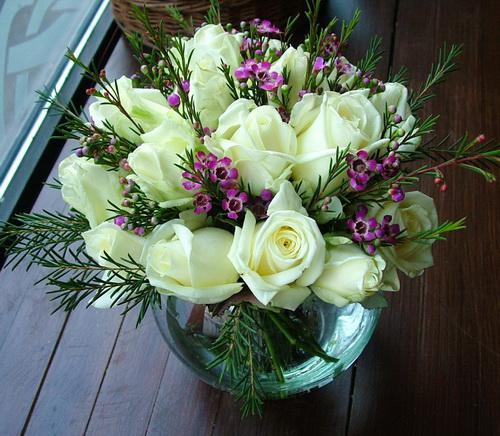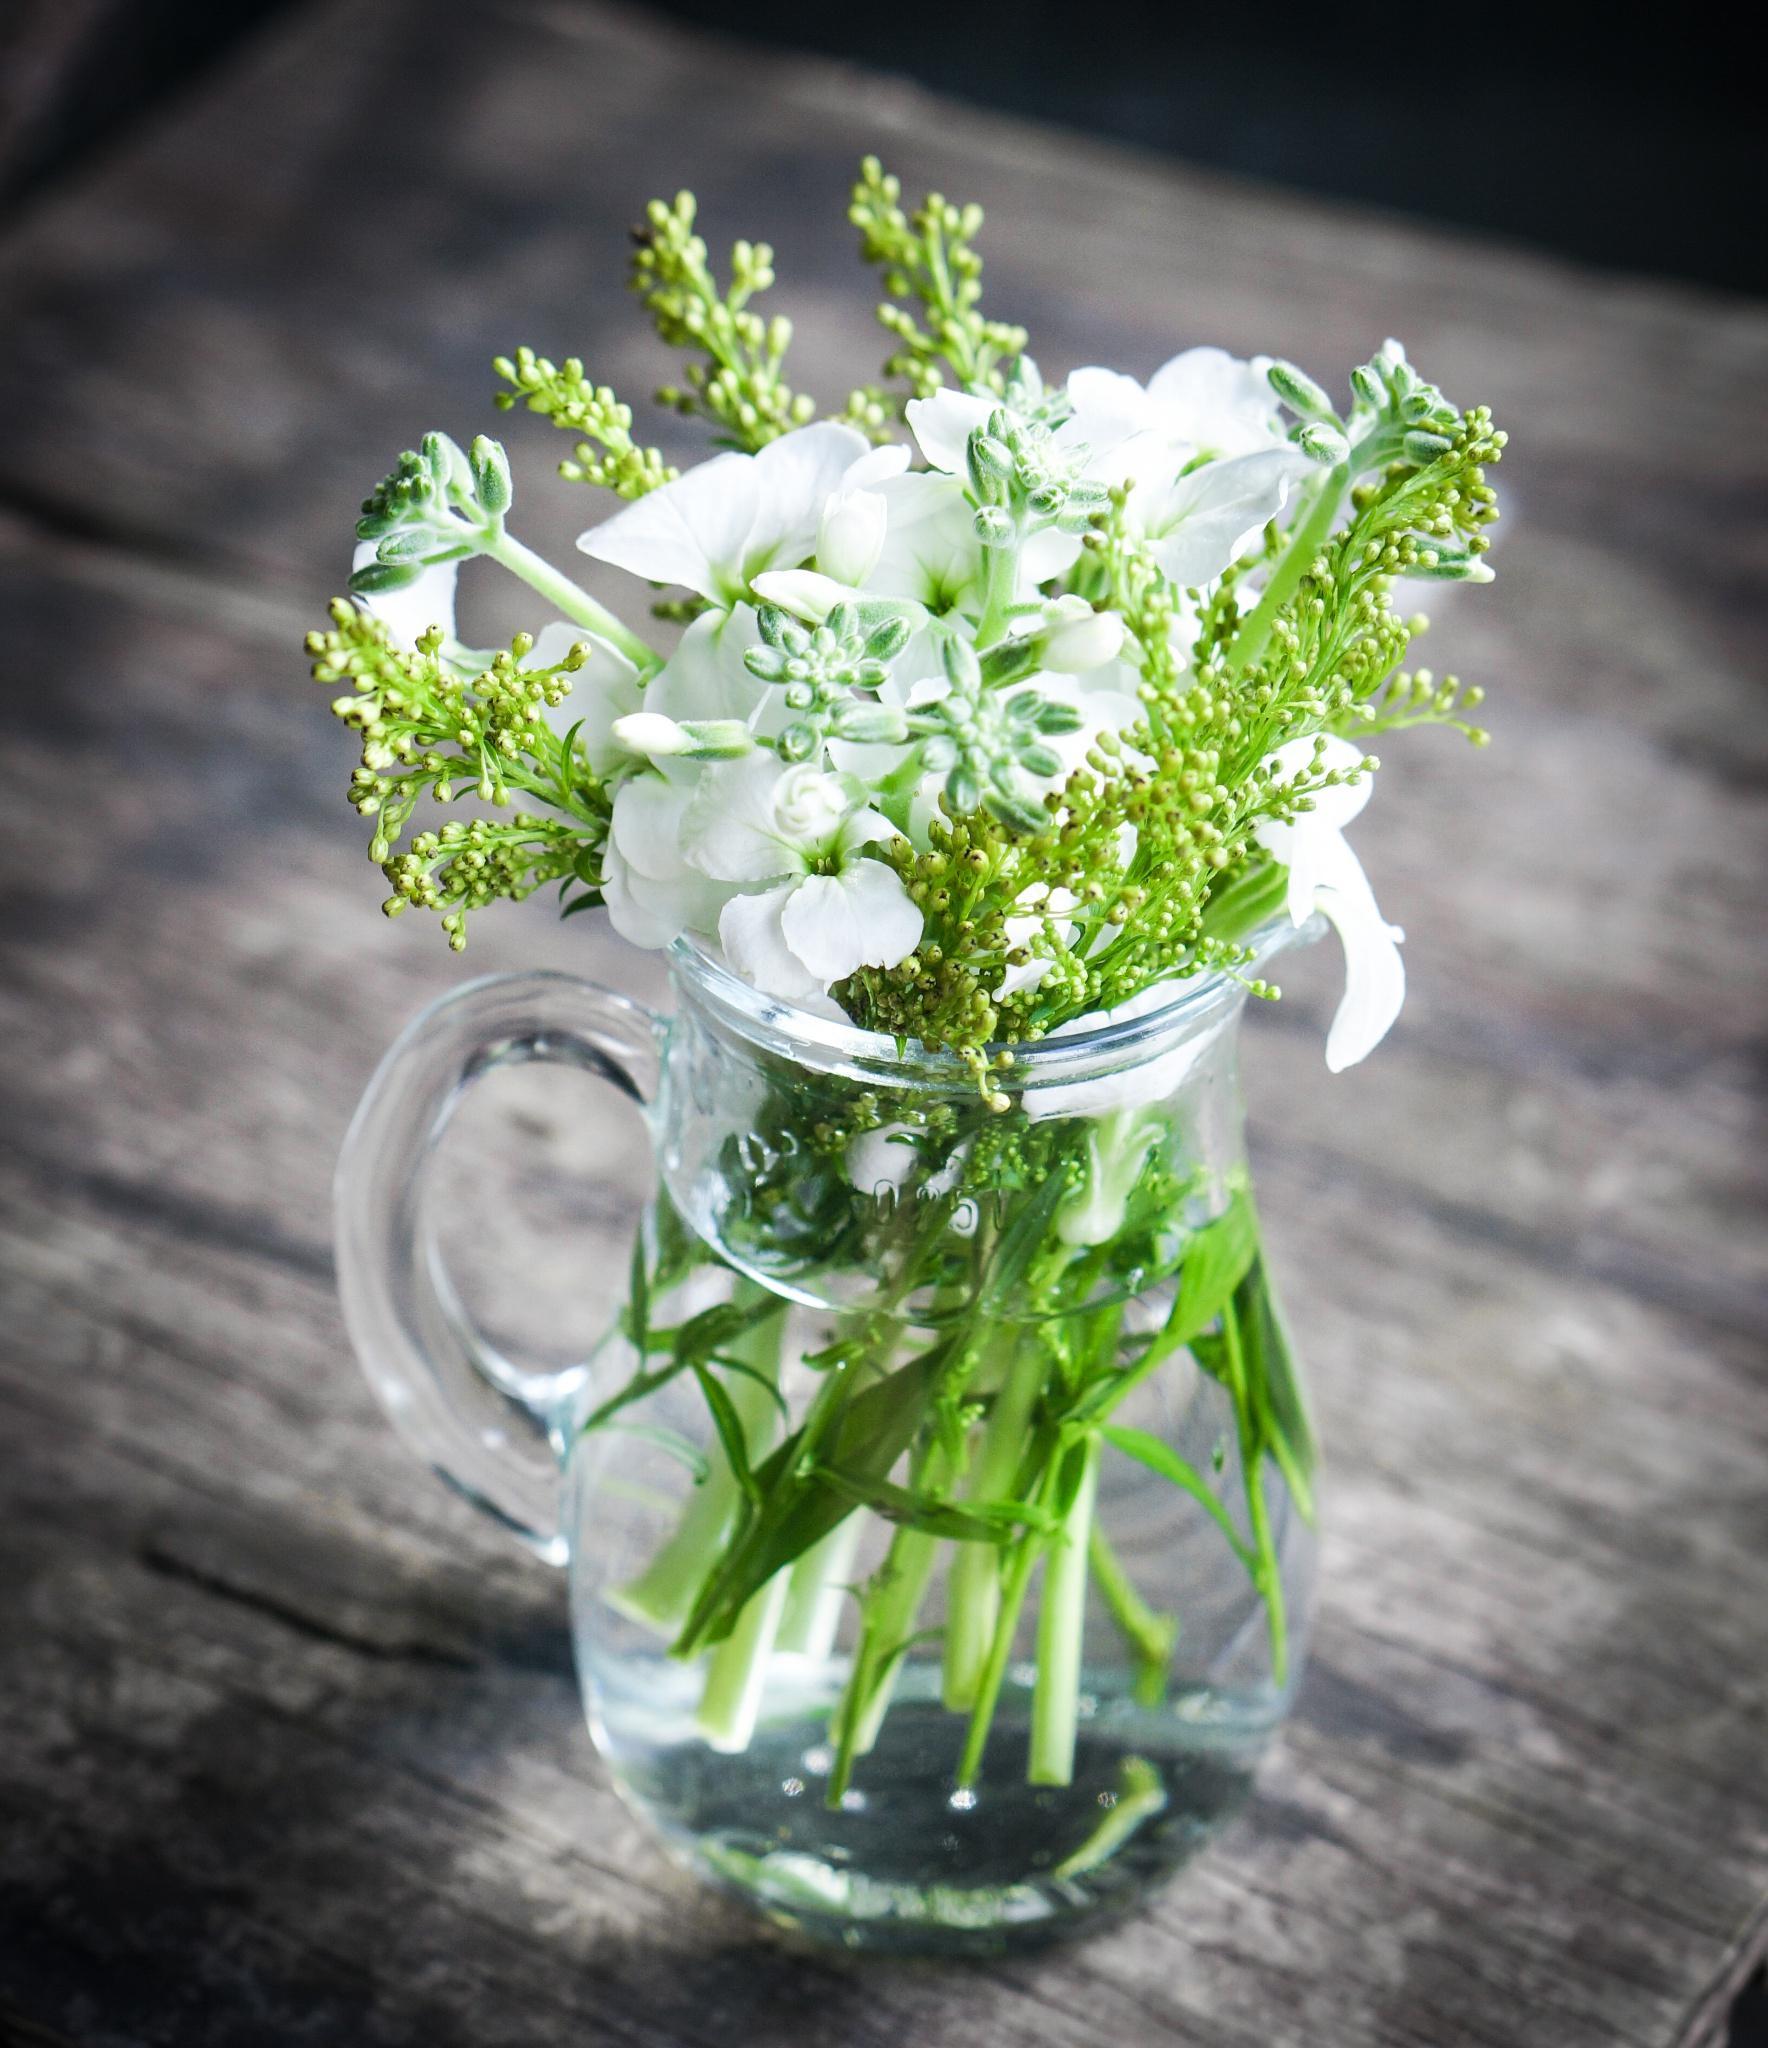The first image is the image on the left, the second image is the image on the right. For the images shown, is this caption "There are flowers in a transparent vase in the image on the right." true? Answer yes or no. Yes. 